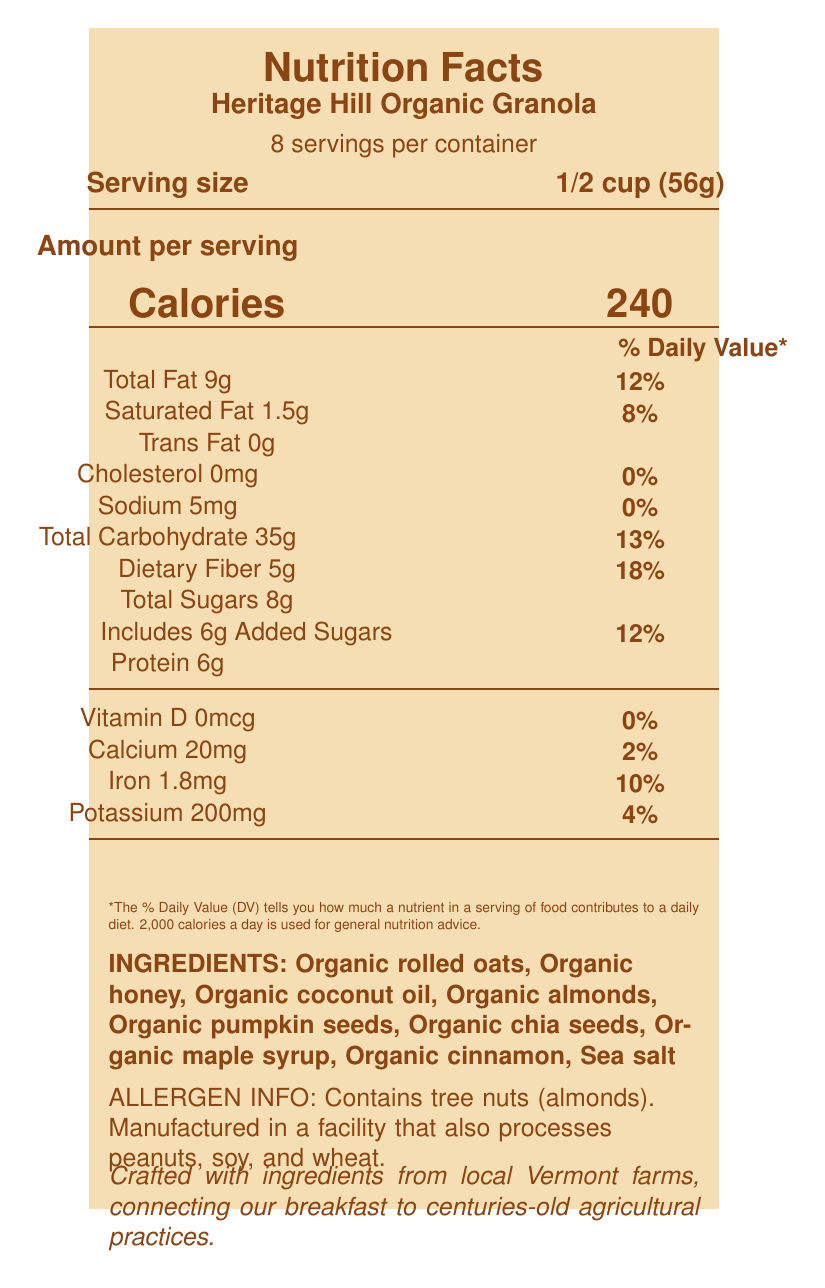what is the product name? The product name is displayed at the top of the document below "Nutrition Facts".
Answer: Heritage Hill Organic Granola what is the serving size for the granola? The serving size is listed under "Serving size" on the document.
Answer: 1/2 cup (56g) how many servings are there per container? The number of servings per container is indicated as "8 servings per container" on the document.
Answer: 8 how many grams of protein are in one serving? The amount of protein per serving is listed as "Protein 6g" on the document.
Answer: 6g what amount of saturated fat is in one serving and what is its daily value percentage? The amount of saturated fat in one serving is listed as "Saturated Fat 1.5g" and its daily value percentage is "8%".
Answer: 1.5g; 8% which ingredients contribute to the dietary fiber content in the granola? The fiber sources include Rolled oats, Chia seeds, Almonds, and Pumpkin seeds.
Answer: Rolled oats, Chia seeds, Almonds, Pumpkin seeds how many grams of total sugars does the granola contain? The total sugars per serving listed on the document is "Total Sugars 8g".
Answer: 8g where are the ingredients sourced from? The ingredients are sourced from local Vermont farms, as mentioned in the product story at the bottom of the document.
Answer: Local Vermont farms which sweeteners are used in the granola? The natural sweeteners listed are Honey and Maple syrup.
Answer: Honey, Maple syrup how many calories are in one serving? The calorie content per serving is listed as "Calories 240" on the document.
Answer: 240 how many milligrams of calcium does one serving contain? The calcium content per serving is listed as "Calcium 20mg".
Answer: 20mg does the granola contain any trans fat? The document lists "Trans Fat 0g", indicating there is no trans fat in the granola.
Answer: No what percentage of the daily value of fiber is provided by one serving? One serving provides "Dietary Fiber 18%" of the daily value.
Answer: 18% how many milligrams of sodium are in one serving? A. 0mg B. 5mg C. 10mg D. 20mg The sodium content per serving is listed as "Sodium 5mg" on the document.
Answer: B what is the percentage of daily value of iron in one serving? A. 2% B. 8% C. 10% D. 12% The document lists "Iron 1.8mg" with a daily value percentage of "10%".
Answer: C does the product contain tree nuts? The allergen information states "Contains tree nuts (almonds)".
Answer: Yes describe the main idea of the document. The document provides a comprehensive breakdown of the nutritional profile and ingredients of the granola, emphasizing its organic and locally sourced ingredients, and also includes a brief note on sustainability and packaging.
Answer: The document is a detailed Nutrition Facts Label for "Heritage Hill Organic Granola", containing information about serving size, nutritional content, ingredients, allergens, and the product's story. It highlights the fiber and natural sweeteners used, as well as the sustainable and local sourcing of ingredients. what is the recommended daily calorie intake this label is based on? At the bottom of the document, it states that the % Daily Value is based on a 2,000 calorie diet.
Answer: 2,000 calories how many ingredients in total does the granola contain? The list mentions the following ingredients: Organic rolled oats, Organic honey, Organic coconut oil, Organic almonds, Organic pumpkin seeds, Organic chia seeds, Organic maple syrup, Organic cinnamon, Sea salt.
Answer: 9 ingredients what are the sustainability practices mentioned in the product story? The document's nutrition facts label mentions local sourcing and recycled packaging but doesn't give detailed sustainability practices in the visual information provided.
Answer: Not enough information can you consume this granola if you are allergic to peanuts? The document states that it is manufactured in a facility that also processes peanuts, which could be a risk for people with peanut allergies.
Answer: No 